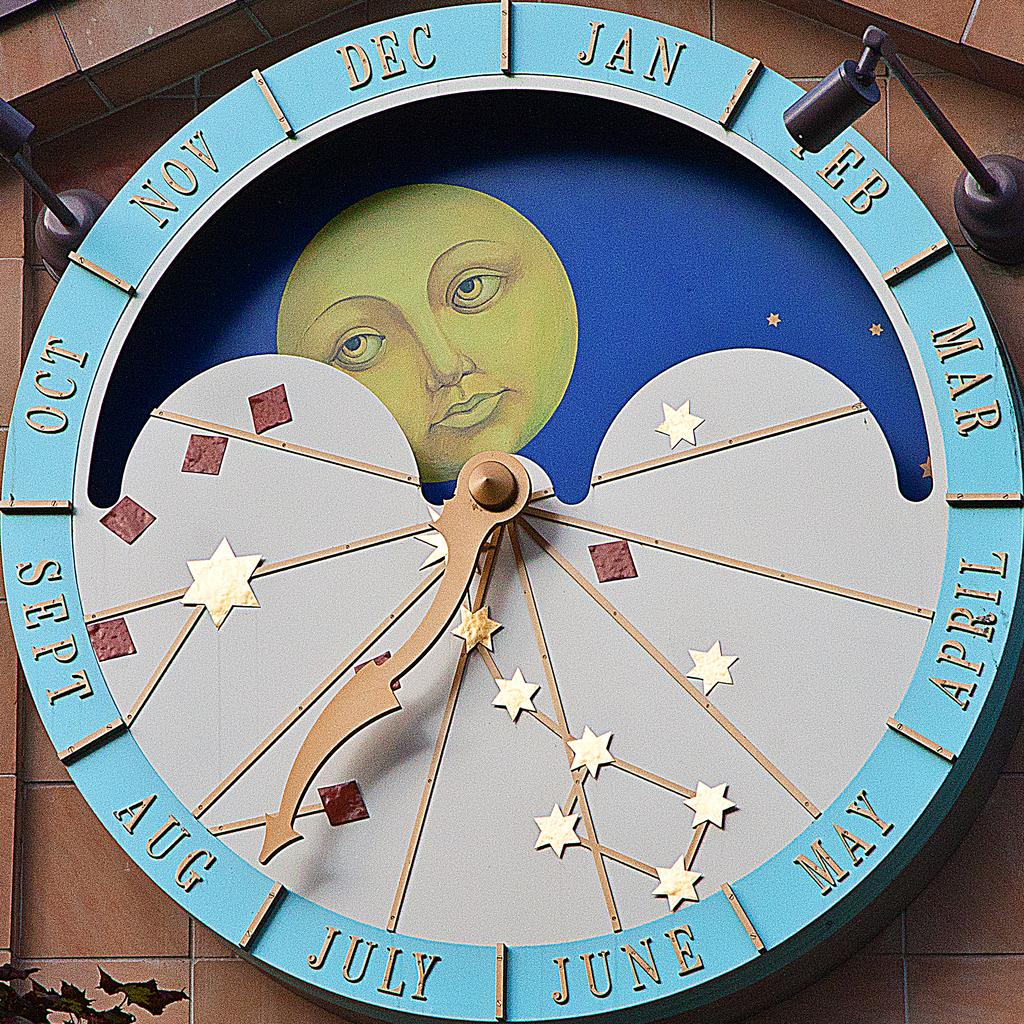Provide a one-sentence caption for the provided image. A round disc has the months around the edge with an arrow pointing to Aug. 